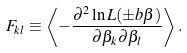<formula> <loc_0><loc_0><loc_500><loc_500>F _ { k l } \equiv \left \langle - \frac { \partial ^ { 2 } \ln { L ( \pm b { \beta } ) } } { \partial \beta _ { k } \partial \beta _ { l } } \right \rangle .</formula> 